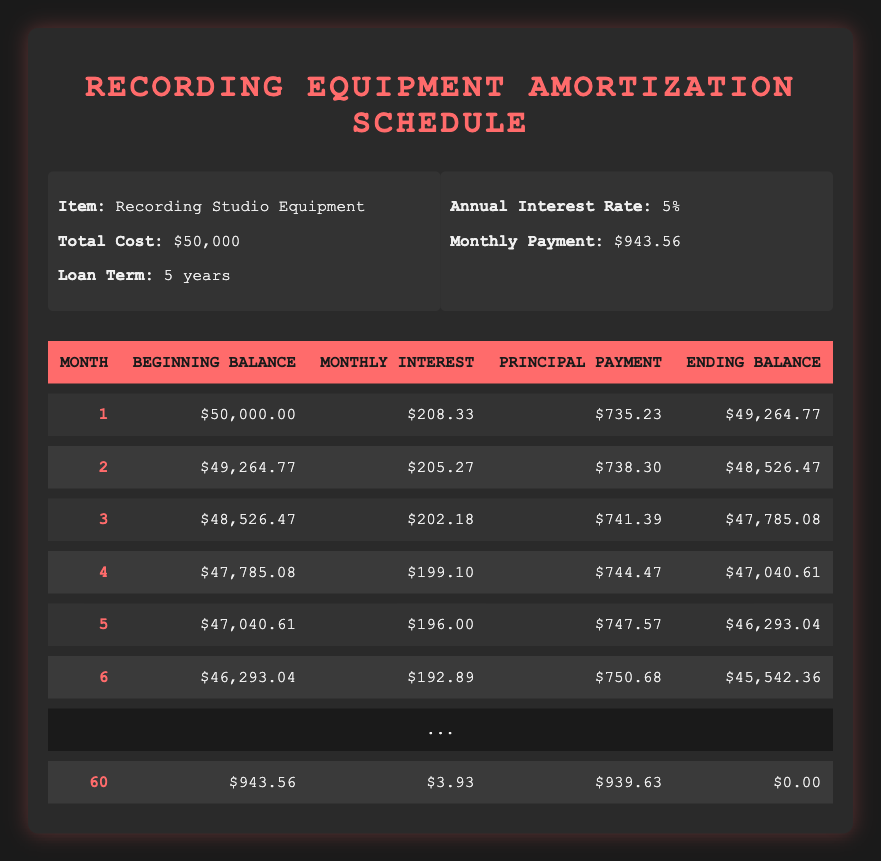What is the monthly payment for the recording equipment financing? The table shows that the monthly payment is stated clearly in the info section as $943.56.
Answer: 943.56 What is the beginning balance for month 3? For month 3, the table lists the beginning balance as $48,526.47.
Answer: 48,526.47 How much principal is paid off in month 5? In month 5, the principal payment is directly listed in the table as $747.57.
Answer: 747.57 What is the total interest paid in the first six months? The interest paid in the first six months can be calculated by summing the monthly interest for those months: 208.33 + 205.27 + 202.18 + 199.10 + 196.00 + 192.89 = 1,204.77.
Answer: 1,204.77 Is the ending balance in month 60 zero? The table shows that the ending balance for month 60 is indeed $0.00, confirming that the loan is fully paid off.
Answer: Yes How many total months are needed to pay off the loan? The loan is structured over 5 years, resulting in 5 years x 12 months/year = 60 months total to pay off the loan.
Answer: 60 What is the average monthly payment over the entire loan period? Since the monthly payment is consistent at $943.56 over 60 months, the average will also be the same: 943.56.
Answer: 943.56 How much total principal is paid off by the end of month 6? To find the total principal paid off by the end of month 6, we sum the principal payments from each of the first six months: 735.23 + 738.30 + 741.39 + 744.47 + 747.57 + 750.68 = 3,757.64.
Answer: 3,757.64 What is the difference in monthly interest between month 1 and month 6? The monthly interest for month 1 is $208.33 and for month 6 is $192.89. The difference is calculated as 208.33 - 192.89 = 15.44.
Answer: 15.44 